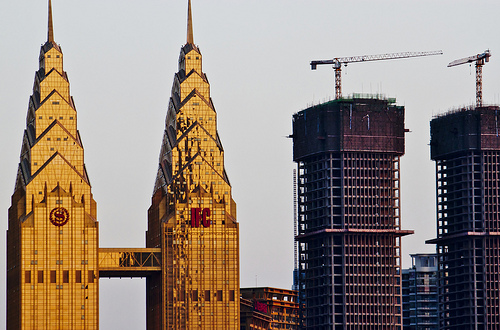<image>
Is there a crane on the building? Yes. Looking at the image, I can see the crane is positioned on top of the building, with the building providing support. 